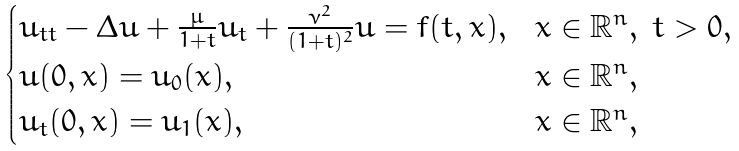<formula> <loc_0><loc_0><loc_500><loc_500>\begin{cases} u _ { t t } - \Delta u + \frac { \mu } { 1 + t } u _ { t } + \frac { \nu ^ { 2 } } { ( 1 + t ) ^ { 2 } } u = f ( t , x ) , & x \in \mathbb { R } ^ { n } , \ t > 0 , \\ u ( 0 , x ) = u _ { 0 } ( x ) , & x \in \mathbb { R } ^ { n } , \\ u _ { t } ( 0 , x ) = u _ { 1 } ( x ) , & x \in \mathbb { R } ^ { n } , \end{cases}</formula> 